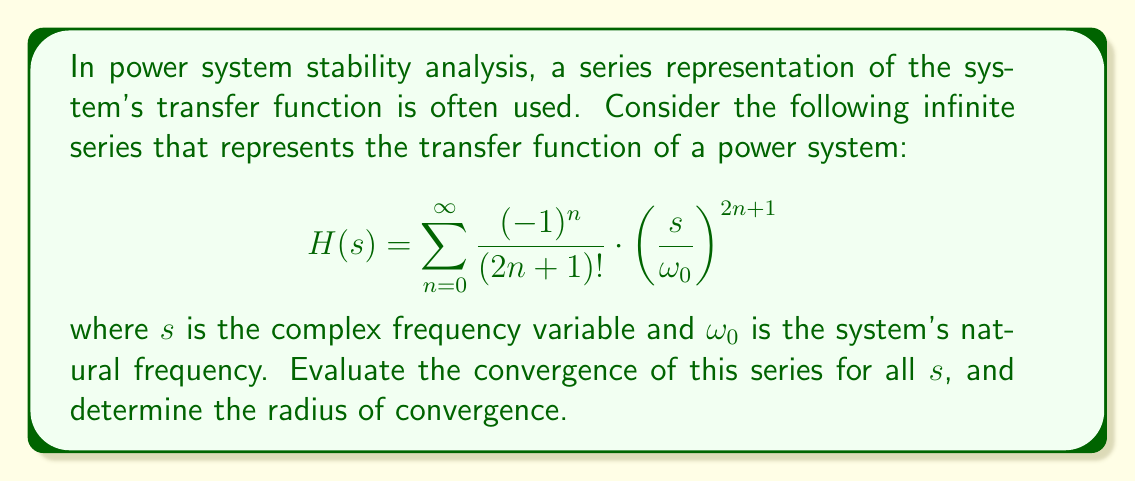Could you help me with this problem? To evaluate the convergence of this infinite series, we'll use the ratio test:

1) First, let's define the general term of the series:

   $$a_n = \frac{(-1)^n}{(2n+1)!} \cdot \left(\frac{s}{\omega_0}\right)^{2n+1}$$

2) Now, we'll calculate the limit of the ratio of successive terms:

   $$\lim_{n \to \infty} \left|\frac{a_{n+1}}{a_n}\right| = \lim_{n \to \infty} \left|\frac{\frac{(-1)^{n+1}}{(2n+3)!} \cdot \left(\frac{s}{\omega_0}\right)^{2n+3}}{\frac{(-1)^n}{(2n+1)!} \cdot \left(\frac{s}{\omega_0}\right)^{2n+1}}\right|$$

3) Simplify:

   $$\lim_{n \to \infty} \left|\frac{(-1)^{n+1}}{(-1)^n} \cdot \frac{(2n+1)!}{(2n+3)!} \cdot \left(\frac{s}{\omega_0}\right)^2\right|$$

4) The $(-1)$ terms cancel out:

   $$\lim_{n \to \infty} \left|\frac{(2n+1)!}{(2n+3)!} \cdot \left(\frac{s}{\omega_0}\right)^2\right|$$

5) Expand the factorial in the denominator:

   $$\lim_{n \to \infty} \left|\frac{1}{(2n+2)(2n+3)} \cdot \left(\frac{s}{\omega_0}\right)^2\right|$$

6) As $n$ approaches infinity, the denominator grows much faster than $\left(\frac{s}{\omega_0}\right)^2$:

   $$\lim_{n \to \infty} \left|\frac{1}{(2n+2)(2n+3)} \cdot \left(\frac{s}{\omega_0}\right)^2\right| = 0$$

7) Since the limit is 0, which is less than 1, the series converges absolutely for all finite values of $s$.

8) To find the radius of convergence, we note that the series converges for all $s$. Therefore, the radius of convergence is infinite.
Answer: The series converges absolutely for all finite values of $s$, and the radius of convergence is infinite. 